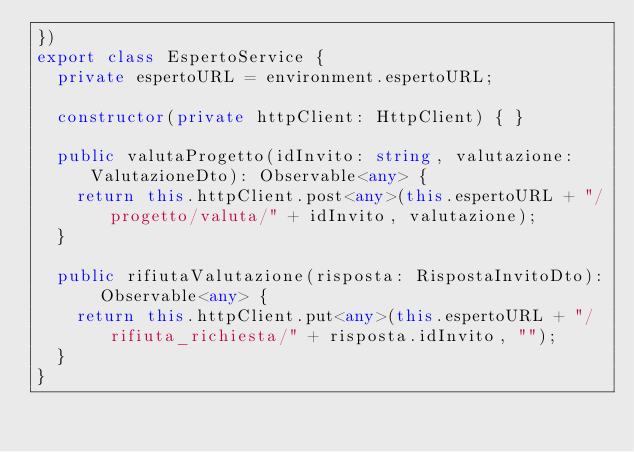<code> <loc_0><loc_0><loc_500><loc_500><_TypeScript_>})
export class EspertoService {
  private espertoURL = environment.espertoURL;

  constructor(private httpClient: HttpClient) { }

  public valutaProgetto(idInvito: string, valutazione: ValutazioneDto): Observable<any> {
    return this.httpClient.post<any>(this.espertoURL + "/progetto/valuta/" + idInvito, valutazione);
  }

  public rifiutaValutazione(risposta: RispostaInvitoDto): Observable<any> {
    return this.httpClient.put<any>(this.espertoURL + "/rifiuta_richiesta/" + risposta.idInvito, "");
  }
}
</code> 